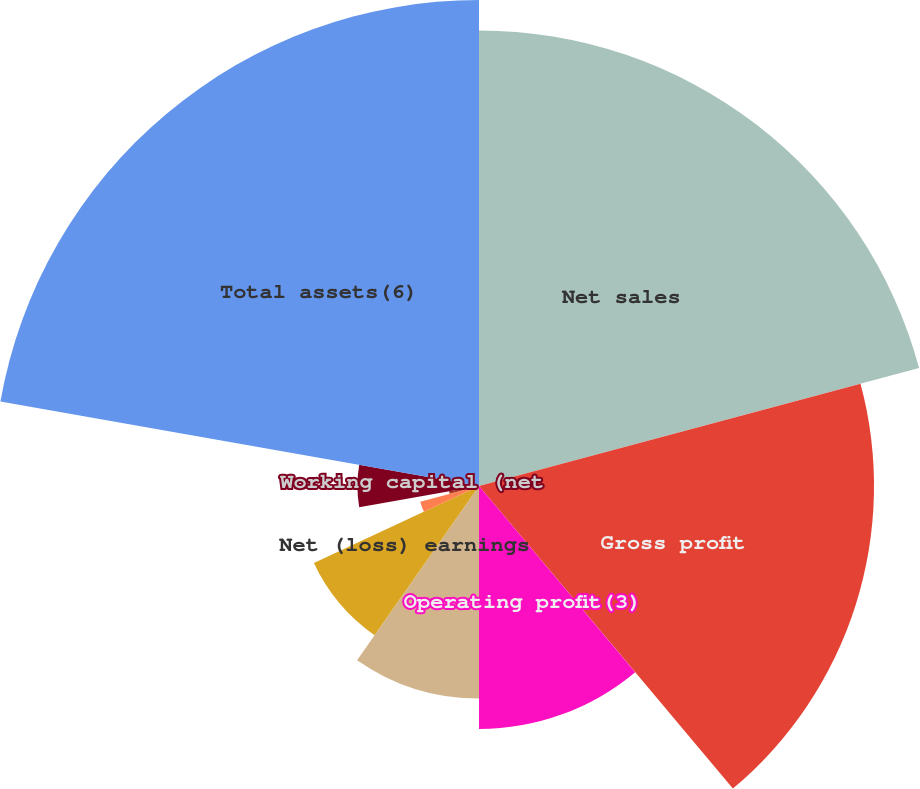<chart> <loc_0><loc_0><loc_500><loc_500><pie_chart><fcel>Net sales<fcel>Gross profit<fcel>Operating profit(3)<fcel>(Loss) earnings before income<fcel>Net (loss) earnings<fcel>Series A convertible preferred<fcel>Basic<fcel>Diluted<fcel>Working capital (net<fcel>Total assets(6)<nl><fcel>20.83%<fcel>18.06%<fcel>11.11%<fcel>9.72%<fcel>8.33%<fcel>2.78%<fcel>1.39%<fcel>0.0%<fcel>5.56%<fcel>22.22%<nl></chart> 